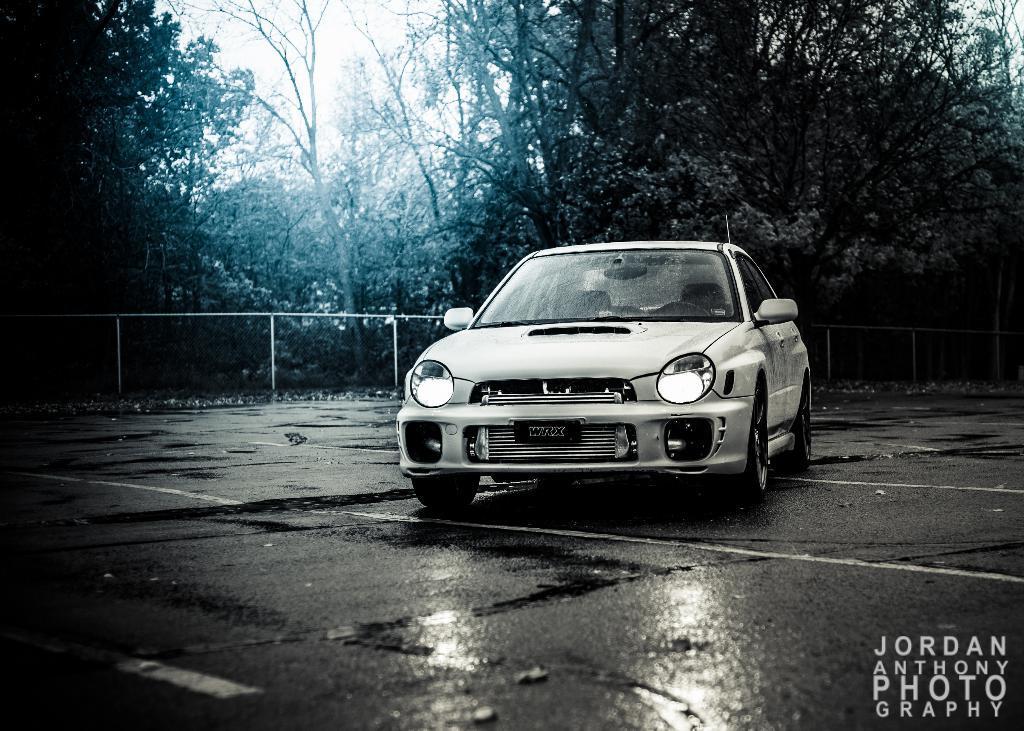Please provide a concise description of this image. In this image we can see a car on the road. In the background we can see a fence, plants, trees, and sky. At the bottom of the image we can see something is written on it. 